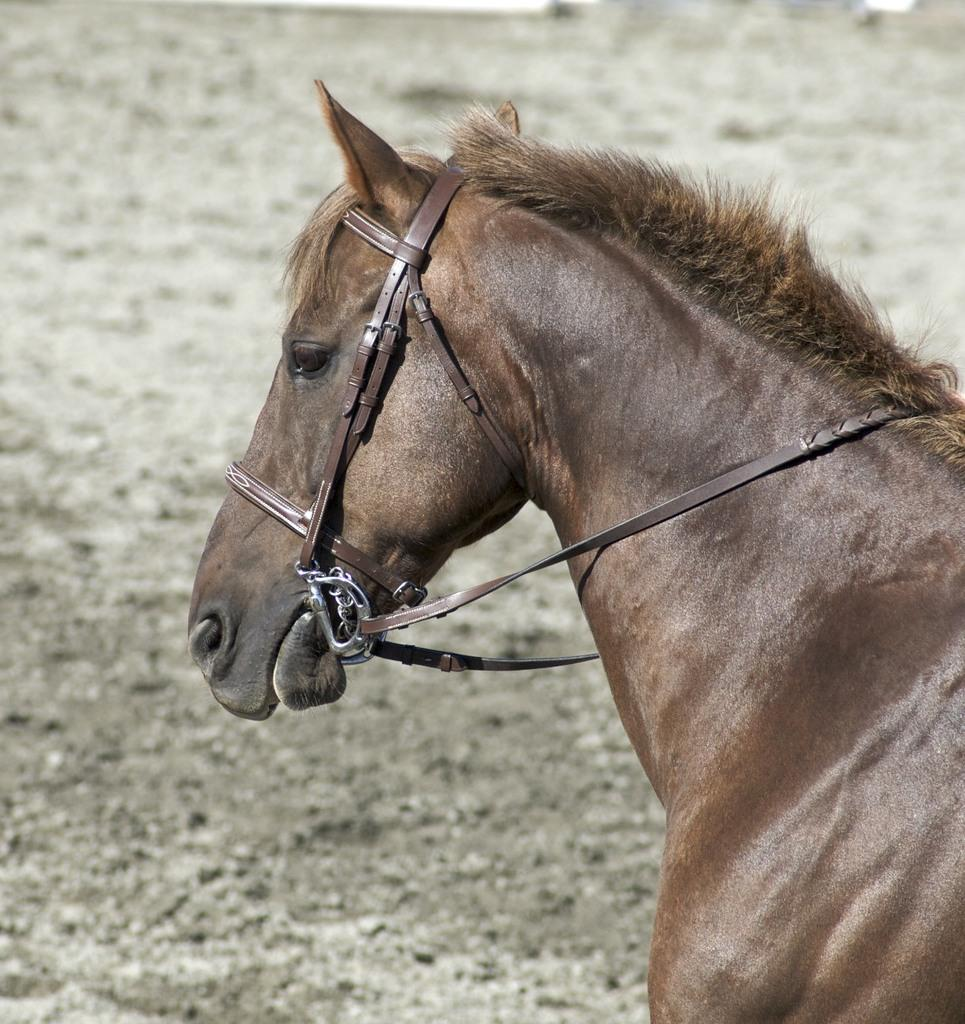What animal is the main subject of the image? There is a horse in the image. Can you describe the background of the image? The background of the horse is blurred. What type of zephyr can be seen in the image? There is no zephyr present in the image; it features a horse with a blurred background. What record is being broken by the horse in the image? There is no record-breaking event depicted in the image; it simply shows a horse with a blurred background. 